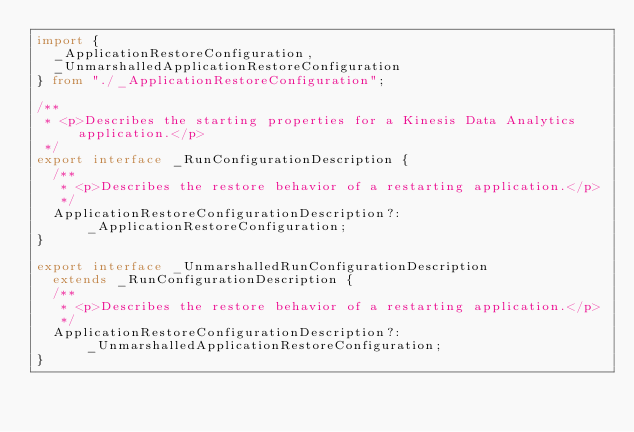Convert code to text. <code><loc_0><loc_0><loc_500><loc_500><_TypeScript_>import {
  _ApplicationRestoreConfiguration,
  _UnmarshalledApplicationRestoreConfiguration
} from "./_ApplicationRestoreConfiguration";

/**
 * <p>Describes the starting properties for a Kinesis Data Analytics application.</p>
 */
export interface _RunConfigurationDescription {
  /**
   * <p>Describes the restore behavior of a restarting application.</p>
   */
  ApplicationRestoreConfigurationDescription?: _ApplicationRestoreConfiguration;
}

export interface _UnmarshalledRunConfigurationDescription
  extends _RunConfigurationDescription {
  /**
   * <p>Describes the restore behavior of a restarting application.</p>
   */
  ApplicationRestoreConfigurationDescription?: _UnmarshalledApplicationRestoreConfiguration;
}
</code> 